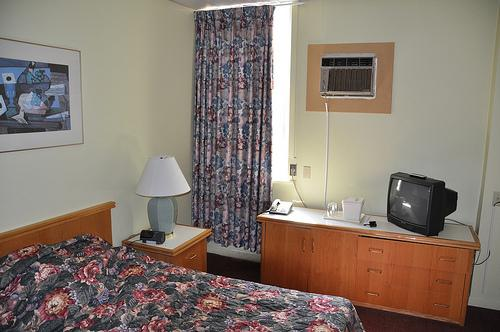Question: where is the phone?
Choices:
A. On the desk.
B. Next to the window.
C. On the chair.
D. On the floor.
Answer with the letter. Answer: B Question: where is the air conditioner plug?
Choices:
A. Next to the curtain.
B. By the door.
C. Under the window.
D. Behind the bookcase.
Answer with the letter. Answer: A Question: where is the painting?
Choices:
A. Above the bed.
B. Over the couch.
C. By the door.
D. Leaning against the wall.
Answer with the letter. Answer: A 